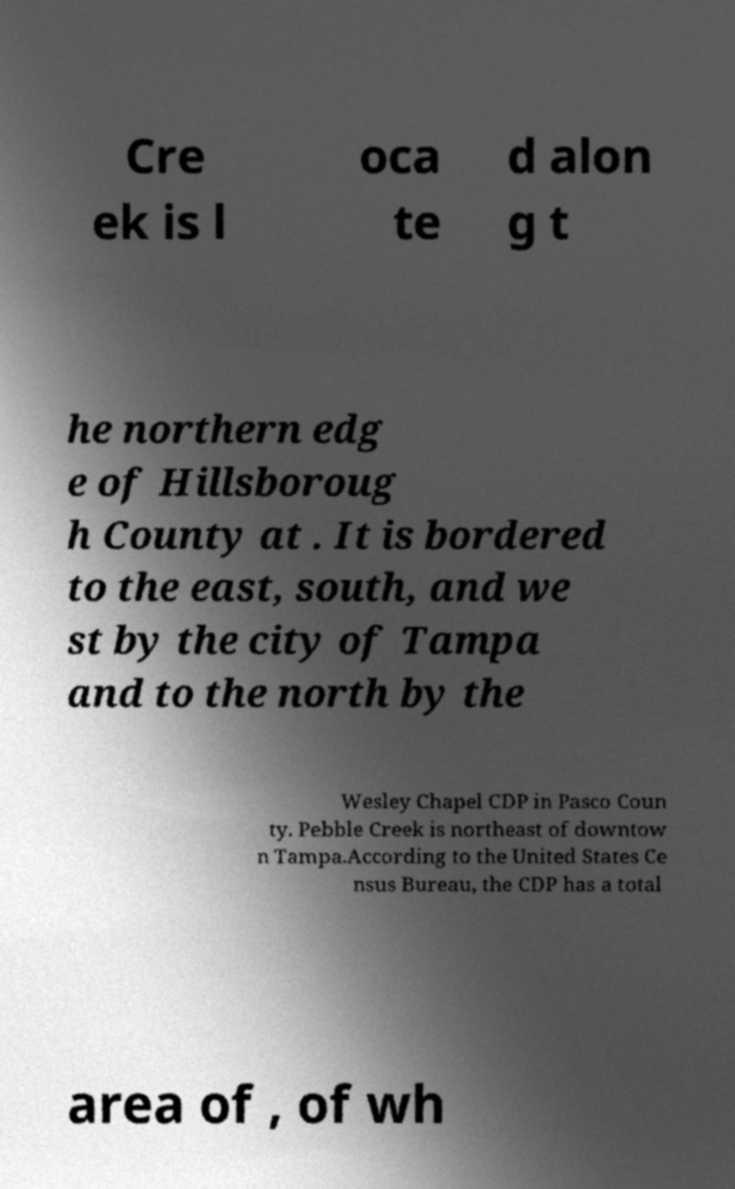There's text embedded in this image that I need extracted. Can you transcribe it verbatim? Cre ek is l oca te d alon g t he northern edg e of Hillsboroug h County at . It is bordered to the east, south, and we st by the city of Tampa and to the north by the Wesley Chapel CDP in Pasco Coun ty. Pebble Creek is northeast of downtow n Tampa.According to the United States Ce nsus Bureau, the CDP has a total area of , of wh 